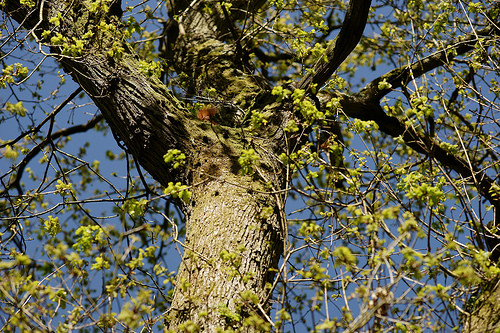<image>
Is there a tree above the flowers? Yes. The tree is positioned above the flowers in the vertical space, higher up in the scene. 